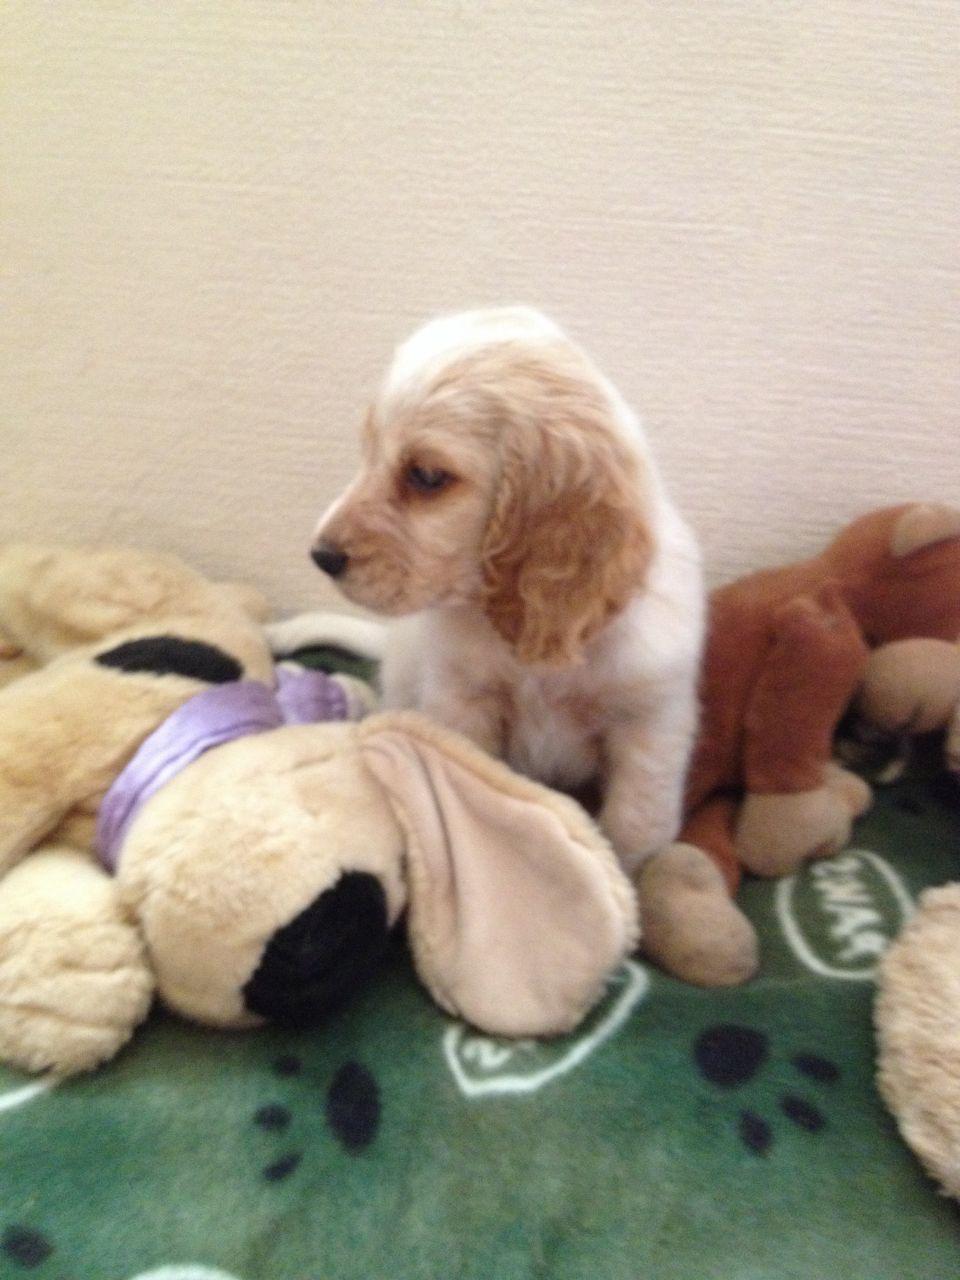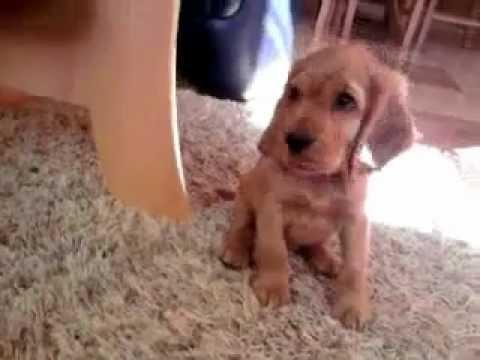The first image is the image on the left, the second image is the image on the right. Considering the images on both sides, is "The right image features at least one spaniel posed on green grass, and the left image contains just one spaniel, which is white with light orange markings." valid? Answer yes or no. No. The first image is the image on the left, the second image is the image on the right. Evaluate the accuracy of this statement regarding the images: "The dogs in all of the images are indoors.". Is it true? Answer yes or no. Yes. 